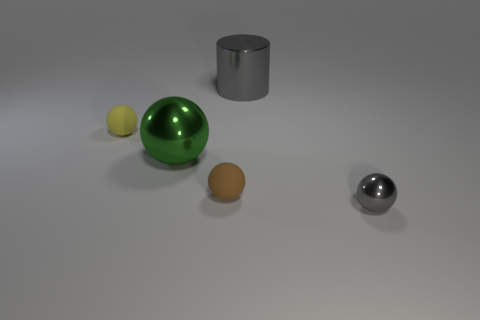There is a tiny thing behind the green shiny sphere; what material is it?
Provide a succinct answer. Rubber. Are there fewer large metallic spheres than gray things?
Your answer should be compact. Yes. Does the brown rubber thing have the same shape as the gray metal object in front of the big gray metal object?
Give a very brief answer. Yes. What shape is the thing that is both right of the small brown matte sphere and on the left side of the tiny gray object?
Your answer should be very brief. Cylinder. Are there the same number of metal cylinders to the left of the large cylinder and rubber spheres that are in front of the large green shiny ball?
Offer a terse response. No. There is a tiny matte thing in front of the small yellow rubber sphere; does it have the same shape as the green shiny thing?
Make the answer very short. Yes. How many brown objects are matte objects or cylinders?
Ensure brevity in your answer.  1. What material is the small yellow object that is the same shape as the small brown thing?
Your answer should be compact. Rubber. What shape is the gray metal thing that is behind the tiny gray metal sphere?
Your response must be concise. Cylinder. Is there a tiny gray thing made of the same material as the big green ball?
Offer a terse response. Yes. 